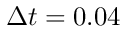Convert formula to latex. <formula><loc_0><loc_0><loc_500><loc_500>\Delta t = 0 . 0 4</formula> 